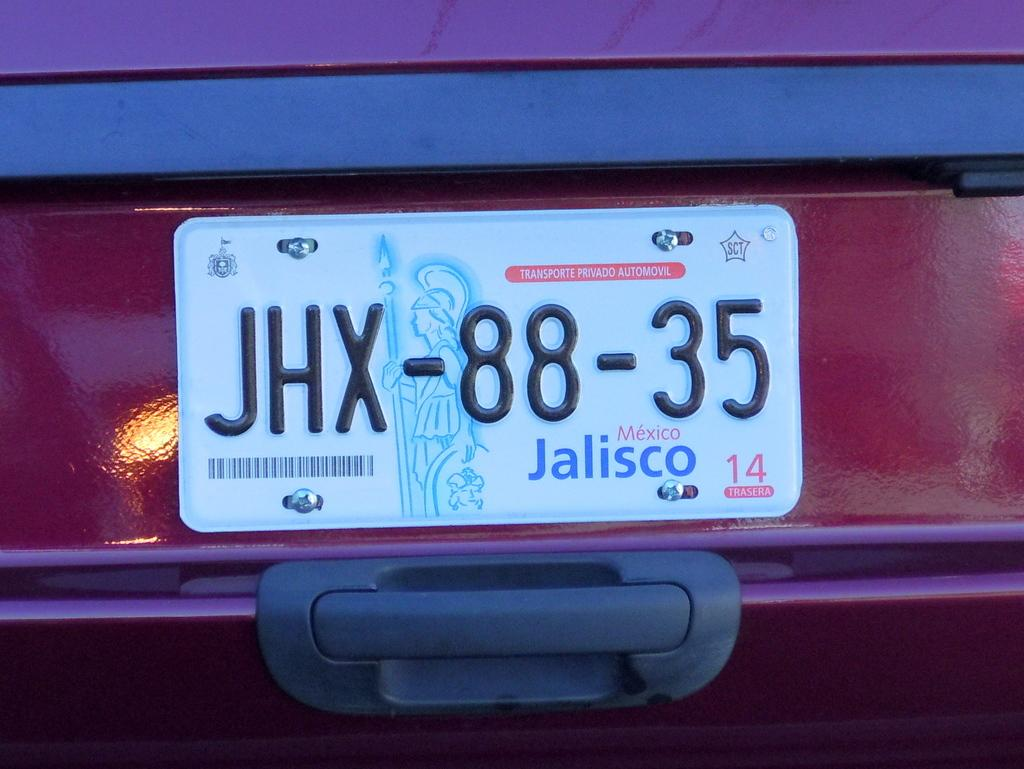<image>
Offer a succinct explanation of the picture presented. A license plate has the word Mexico on it. 